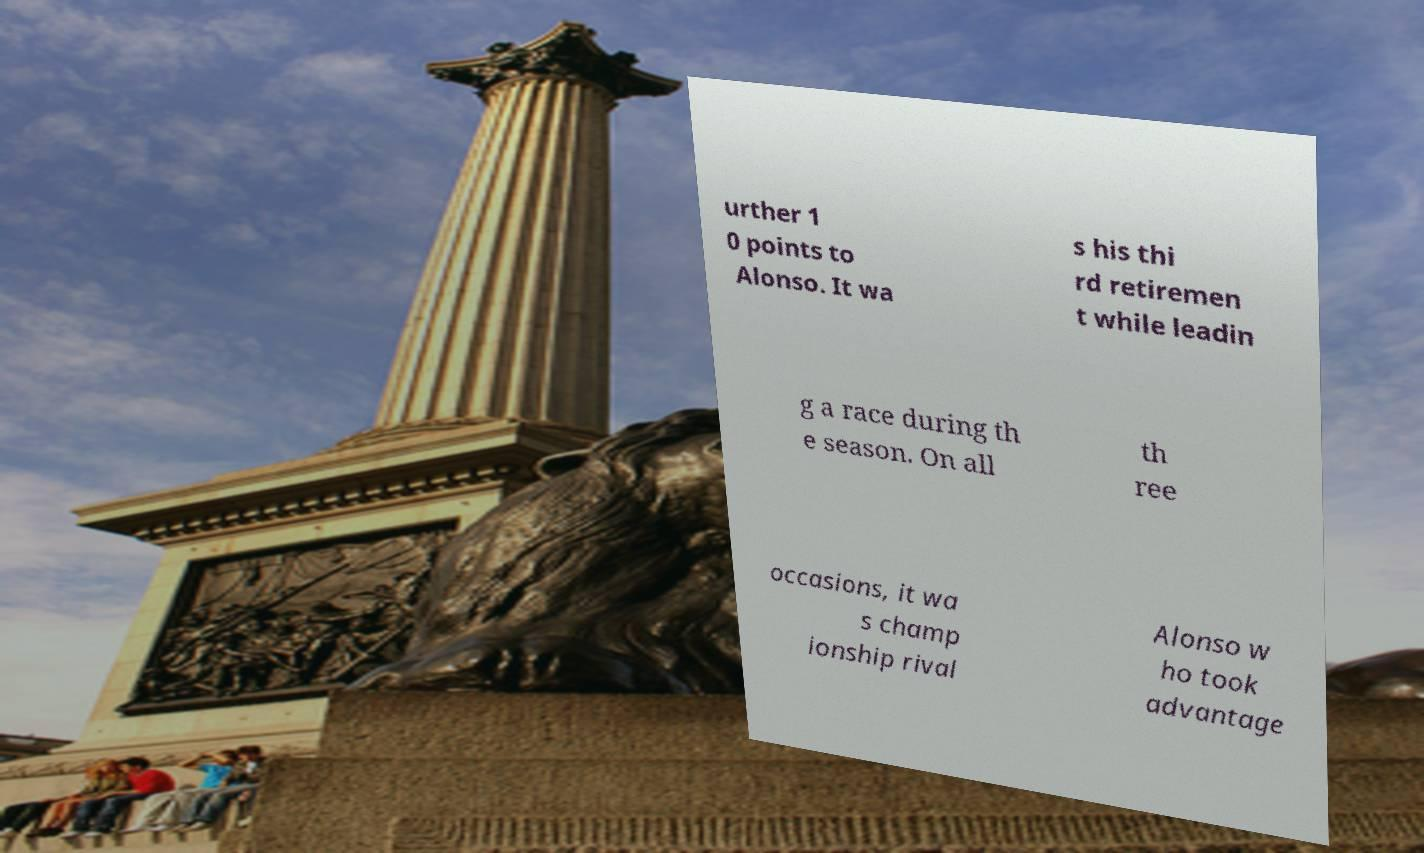Please read and relay the text visible in this image. What does it say? urther 1 0 points to Alonso. It wa s his thi rd retiremen t while leadin g a race during th e season. On all th ree occasions, it wa s champ ionship rival Alonso w ho took advantage 